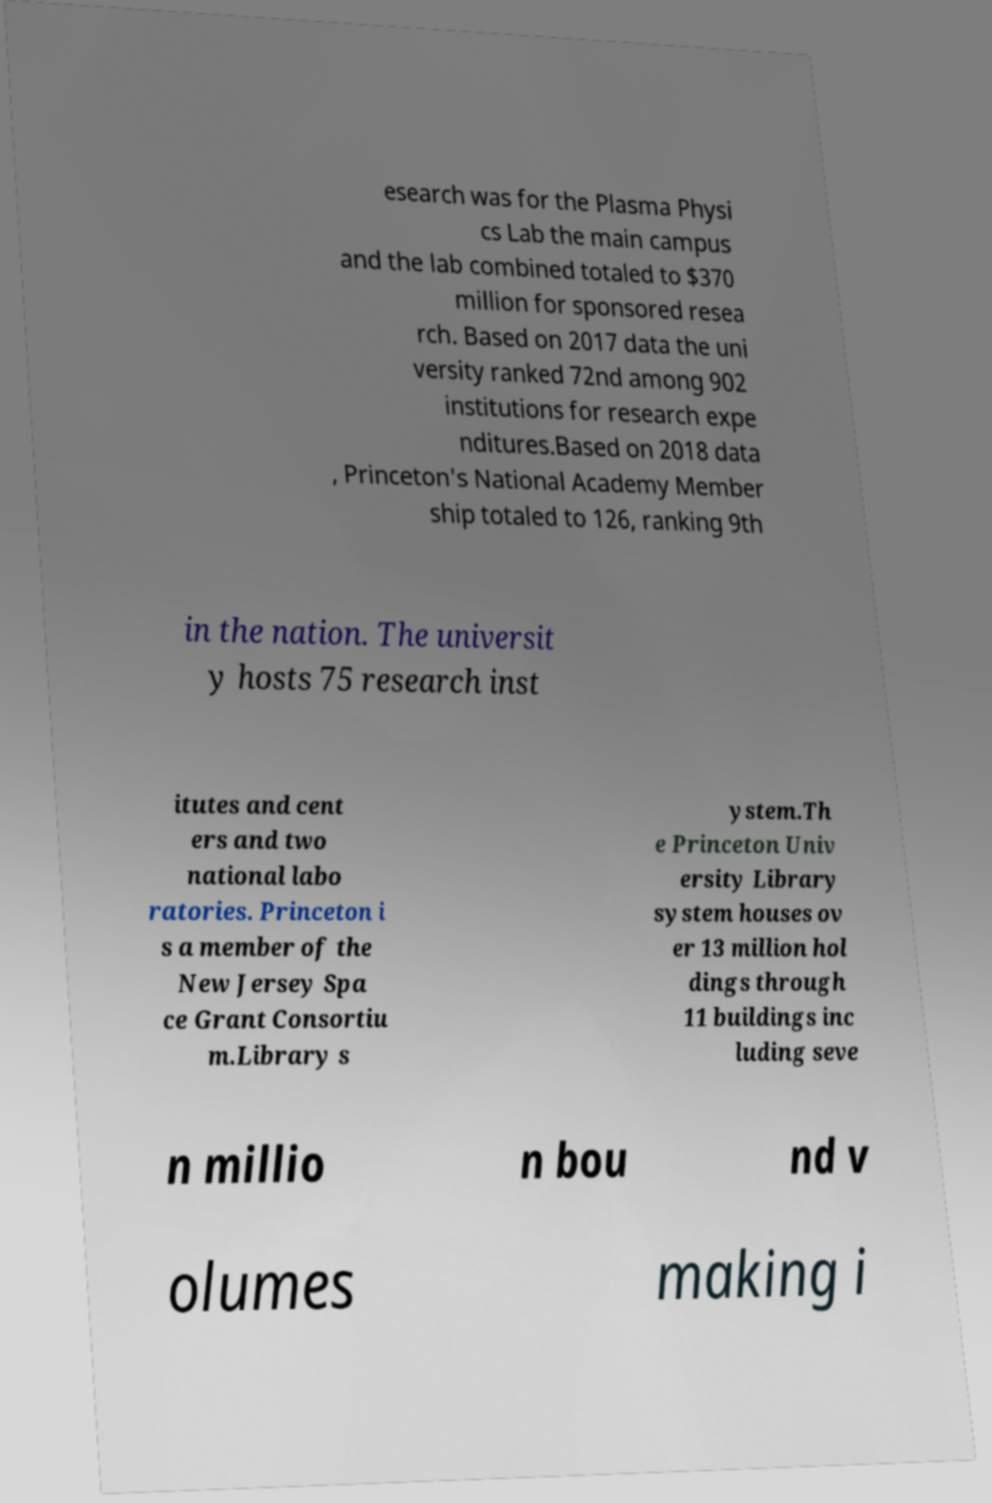Could you extract and type out the text from this image? esearch was for the Plasma Physi cs Lab the main campus and the lab combined totaled to $370 million for sponsored resea rch. Based on 2017 data the uni versity ranked 72nd among 902 institutions for research expe nditures.Based on 2018 data , Princeton's National Academy Member ship totaled to 126, ranking 9th in the nation. The universit y hosts 75 research inst itutes and cent ers and two national labo ratories. Princeton i s a member of the New Jersey Spa ce Grant Consortiu m.Library s ystem.Th e Princeton Univ ersity Library system houses ov er 13 million hol dings through 11 buildings inc luding seve n millio n bou nd v olumes making i 